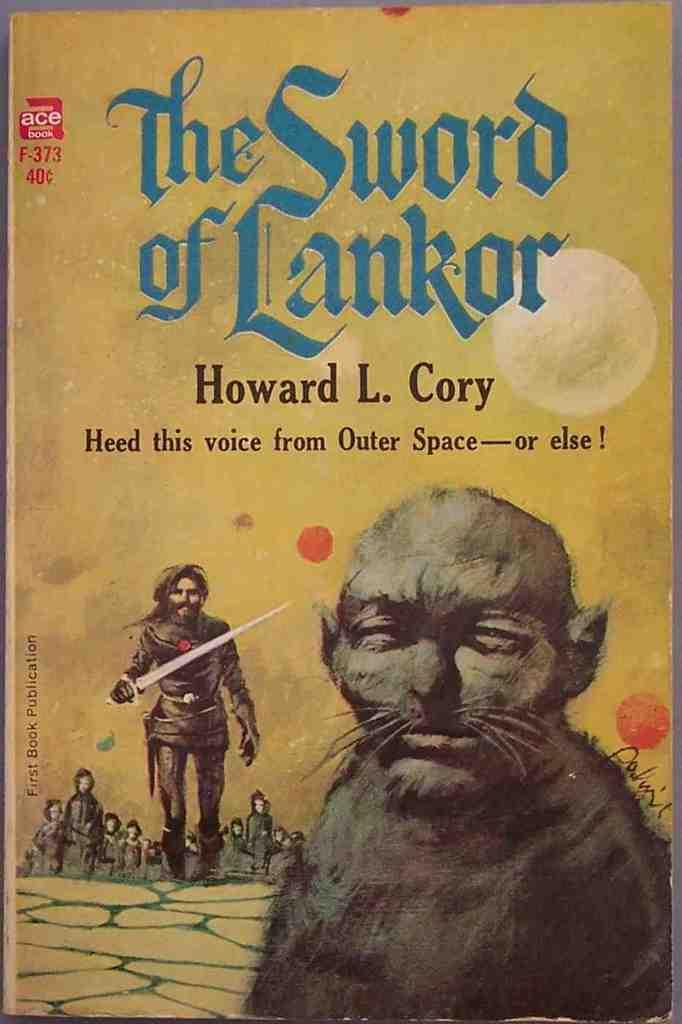<image>
Share a concise interpretation of the image provided. A creature is featured in the foreground of The Sword of Lanker. 